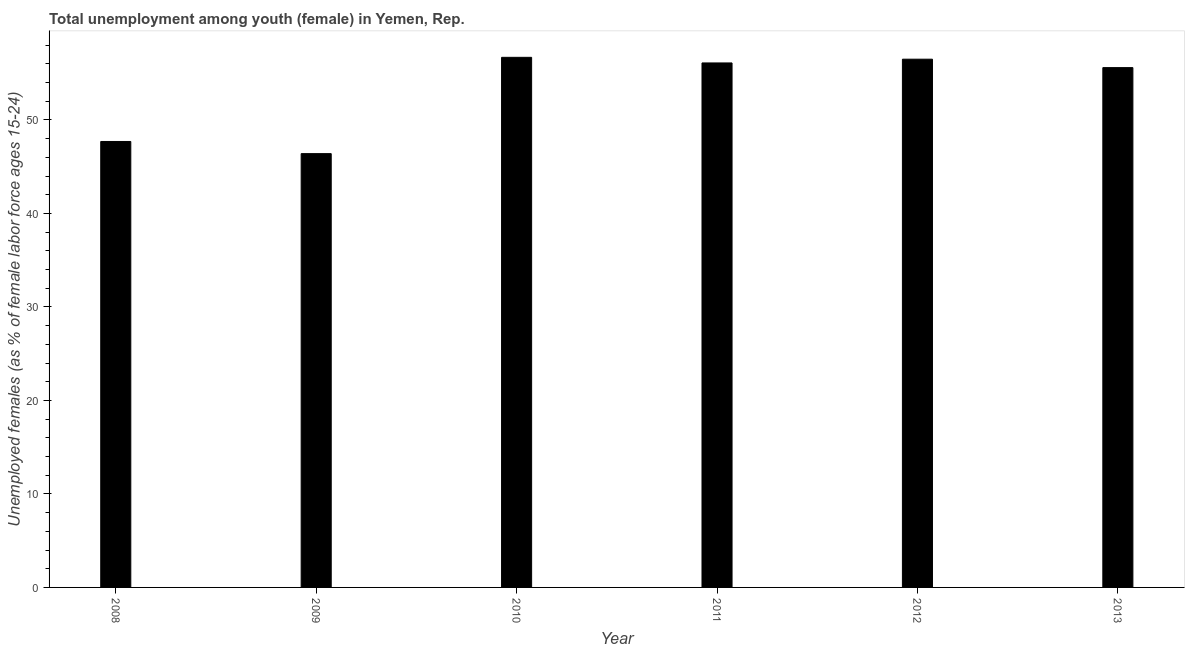What is the title of the graph?
Your response must be concise. Total unemployment among youth (female) in Yemen, Rep. What is the label or title of the Y-axis?
Offer a terse response. Unemployed females (as % of female labor force ages 15-24). What is the unemployed female youth population in 2008?
Offer a very short reply. 47.7. Across all years, what is the maximum unemployed female youth population?
Provide a succinct answer. 56.7. Across all years, what is the minimum unemployed female youth population?
Provide a succinct answer. 46.4. In which year was the unemployed female youth population maximum?
Your answer should be compact. 2010. What is the sum of the unemployed female youth population?
Offer a very short reply. 319. What is the average unemployed female youth population per year?
Give a very brief answer. 53.17. What is the median unemployed female youth population?
Keep it short and to the point. 55.85. In how many years, is the unemployed female youth population greater than 42 %?
Your answer should be compact. 6. Is the unemployed female youth population in 2010 less than that in 2013?
Your answer should be very brief. No. Is the difference between the unemployed female youth population in 2010 and 2012 greater than the difference between any two years?
Offer a very short reply. No. Is the sum of the unemployed female youth population in 2009 and 2013 greater than the maximum unemployed female youth population across all years?
Your answer should be compact. Yes. What is the difference between the highest and the lowest unemployed female youth population?
Offer a very short reply. 10.3. How many years are there in the graph?
Your response must be concise. 6. What is the difference between two consecutive major ticks on the Y-axis?
Your response must be concise. 10. Are the values on the major ticks of Y-axis written in scientific E-notation?
Keep it short and to the point. No. What is the Unemployed females (as % of female labor force ages 15-24) in 2008?
Provide a short and direct response. 47.7. What is the Unemployed females (as % of female labor force ages 15-24) in 2009?
Your answer should be very brief. 46.4. What is the Unemployed females (as % of female labor force ages 15-24) of 2010?
Offer a very short reply. 56.7. What is the Unemployed females (as % of female labor force ages 15-24) of 2011?
Your response must be concise. 56.1. What is the Unemployed females (as % of female labor force ages 15-24) of 2012?
Give a very brief answer. 56.5. What is the Unemployed females (as % of female labor force ages 15-24) in 2013?
Your response must be concise. 55.6. What is the difference between the Unemployed females (as % of female labor force ages 15-24) in 2008 and 2013?
Make the answer very short. -7.9. What is the difference between the Unemployed females (as % of female labor force ages 15-24) in 2009 and 2010?
Give a very brief answer. -10.3. What is the difference between the Unemployed females (as % of female labor force ages 15-24) in 2009 and 2013?
Your response must be concise. -9.2. What is the difference between the Unemployed females (as % of female labor force ages 15-24) in 2010 and 2011?
Give a very brief answer. 0.6. What is the difference between the Unemployed females (as % of female labor force ages 15-24) in 2010 and 2012?
Your answer should be very brief. 0.2. What is the difference between the Unemployed females (as % of female labor force ages 15-24) in 2010 and 2013?
Ensure brevity in your answer.  1.1. What is the difference between the Unemployed females (as % of female labor force ages 15-24) in 2011 and 2013?
Provide a succinct answer. 0.5. What is the difference between the Unemployed females (as % of female labor force ages 15-24) in 2012 and 2013?
Offer a very short reply. 0.9. What is the ratio of the Unemployed females (as % of female labor force ages 15-24) in 2008 to that in 2009?
Offer a very short reply. 1.03. What is the ratio of the Unemployed females (as % of female labor force ages 15-24) in 2008 to that in 2010?
Your answer should be very brief. 0.84. What is the ratio of the Unemployed females (as % of female labor force ages 15-24) in 2008 to that in 2012?
Your answer should be compact. 0.84. What is the ratio of the Unemployed females (as % of female labor force ages 15-24) in 2008 to that in 2013?
Give a very brief answer. 0.86. What is the ratio of the Unemployed females (as % of female labor force ages 15-24) in 2009 to that in 2010?
Give a very brief answer. 0.82. What is the ratio of the Unemployed females (as % of female labor force ages 15-24) in 2009 to that in 2011?
Offer a terse response. 0.83. What is the ratio of the Unemployed females (as % of female labor force ages 15-24) in 2009 to that in 2012?
Your response must be concise. 0.82. What is the ratio of the Unemployed females (as % of female labor force ages 15-24) in 2009 to that in 2013?
Your answer should be compact. 0.83. What is the ratio of the Unemployed females (as % of female labor force ages 15-24) in 2010 to that in 2013?
Give a very brief answer. 1.02. What is the ratio of the Unemployed females (as % of female labor force ages 15-24) in 2012 to that in 2013?
Make the answer very short. 1.02. 